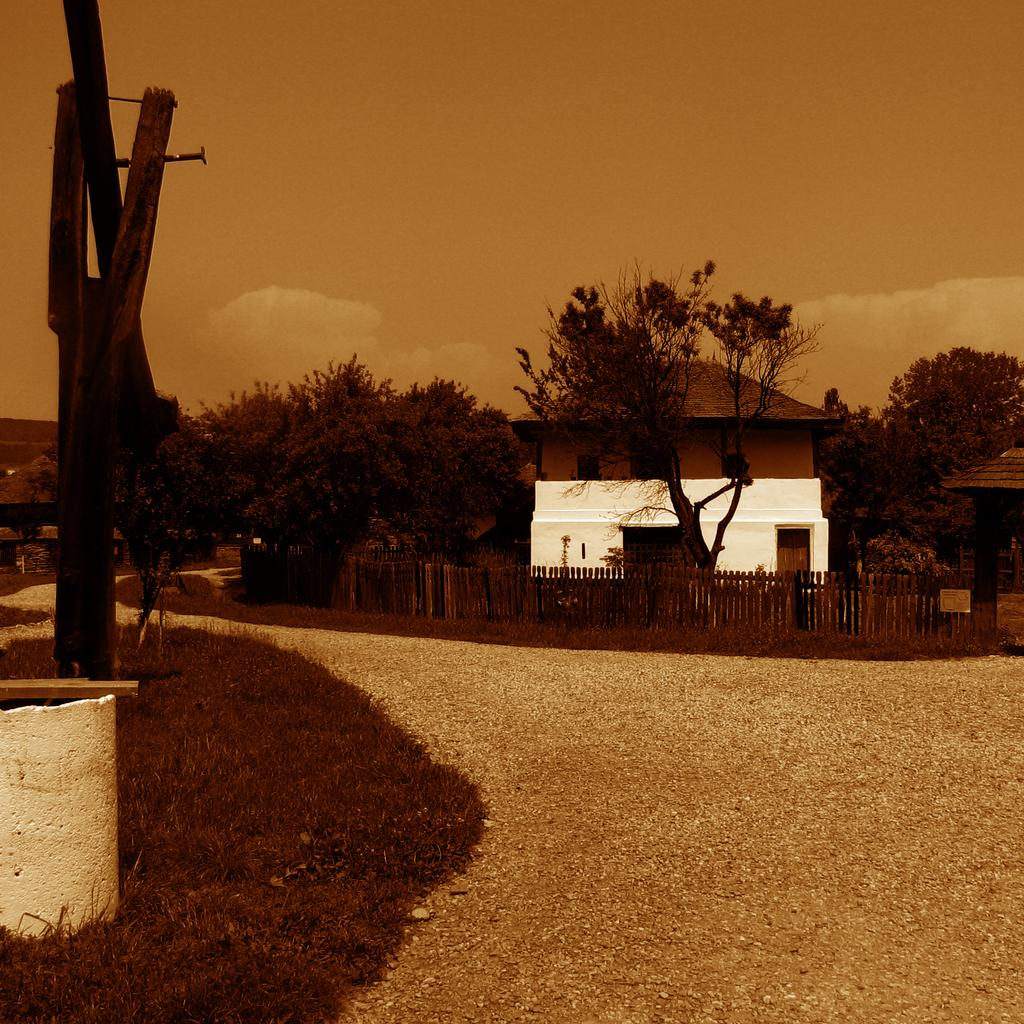What type of vegetation can be seen in the image? There is grass in the image. What can be used for walking or traversing in the image? There are walkways in the image. What type of structures are present in the image? There are houses in the image. What other natural elements can be seen in the image? There are trees in the image. What is used to separate or enclose areas in the image? There is fencing in the image. What other objects are present in the image? There are some objects in the image. What type of architectural features can be seen in the image? There are walls in the image. What is visible in the background of the image? The sky is visible in the background of the image. How does the wax melt in the image? There is no wax present in the image, so it cannot melt. What direction does the side of the house face in the image? The image does not provide information about the direction the houses are facing, so it cannot be determined. 